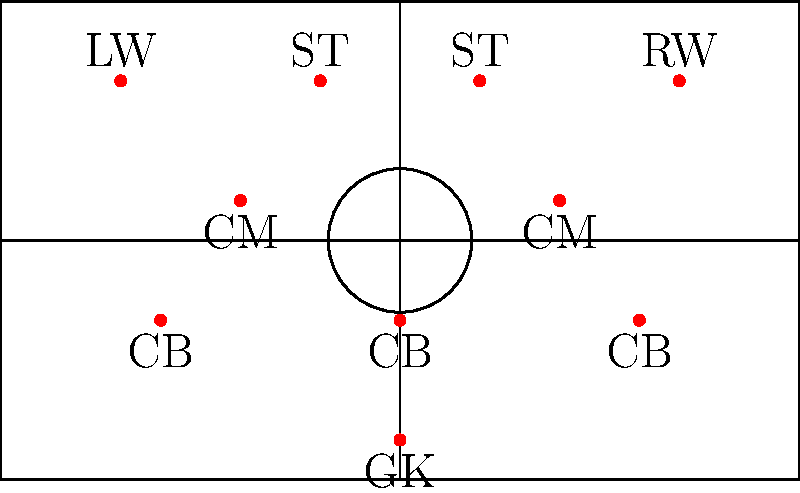Based on the player positions shown in the soccer field diagram, what formation is Rapid Wien likely employing, and how might this formation benefit their playing style? To determine the formation and its benefits for Rapid Wien, let's analyze the player positions step-by-step:

1. Defensive line: There are 3 players positioned as center-backs (CB), indicating a three-man defense.

2. Midfield: We see 2 central midfielders (CM) positioned slightly ahead of the defensive line.

3. Attack: There are 4 players in advanced positions - 2 wide players (LW and RW) and 2 central strikers (ST).

4. Goalkeeper: As always, there is 1 goalkeeper (GK) in the standard position.

Counting the players from back to front, we can identify this as a 3-5-2 formation:
- 3 defenders
- 5 midfielders (including the 2 CM and 2 wide players who can act as wing-backs)
- 2 strikers

This 3-5-2 formation can benefit Rapid Wien's playing style in several ways:

a) Defensive solidity: The three-man defense provides a strong base, allowing the team to defend against opposing attacks effectively.

b) Midfield control: With five midfielders, Rapid Wien can dominate possession and control the tempo of the game.

c) Width in attack: The wing-backs (LW and RW) can provide width and crossing opportunities, stretching the opponent's defense.

d) Striking partnership: Two strikers up front allow for better link-up play and more goalscoring opportunities.

e) Flexibility: This formation can easily transition to a 5-3-2 when defending, with the wing-backs dropping back to form a five-man defense.
Answer: 3-5-2 formation 